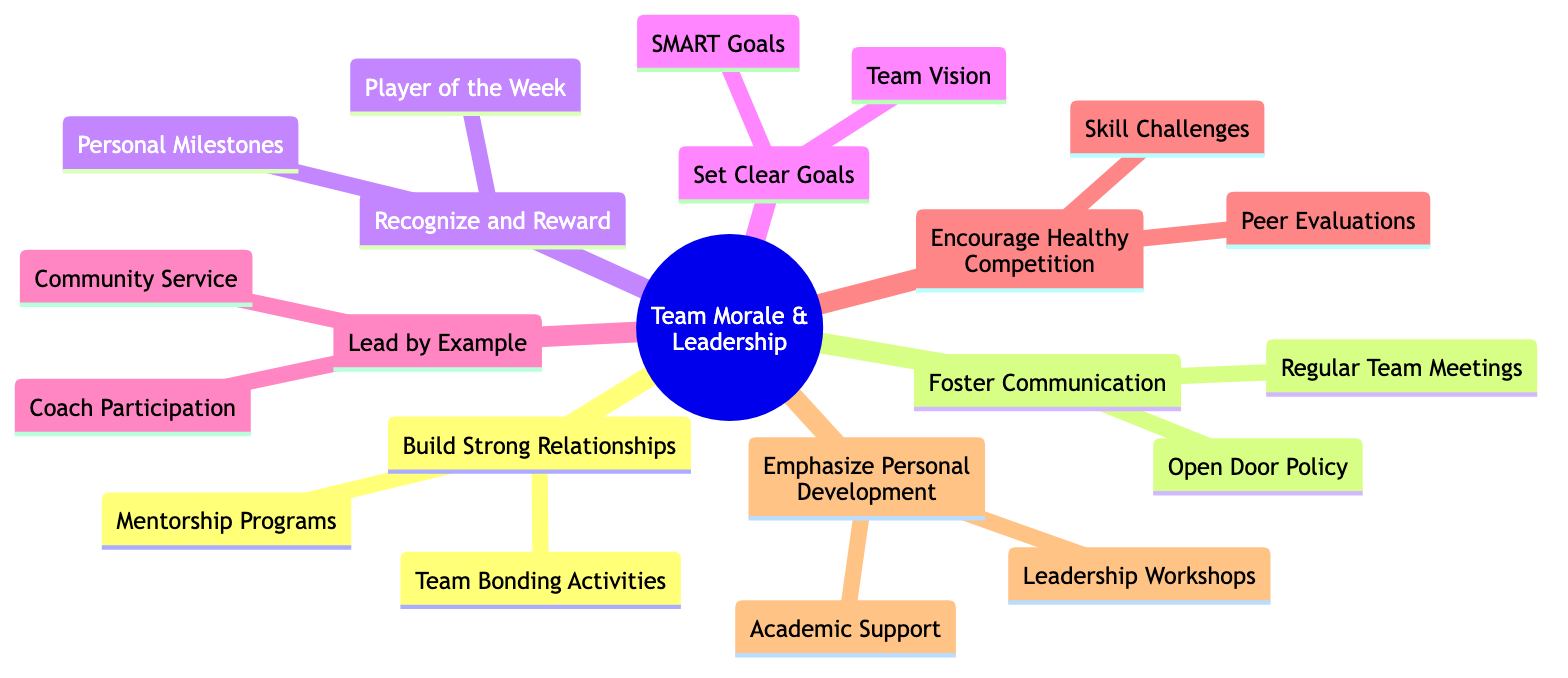What is one method for building strong relationships in the team? The diagram shows that one way to build strong relationships is through team bonding activities, which include organizing events like team dinners or movie nights.
Answer: Team Bonding Activities How many main strategies are outlined in the diagram? The diagram lists seven main strategies, each represented as a main branch extending from the central idea.
Answer: 7 What type of policy is encouraged to foster communication? The diagram indicates that an open door policy is suggested to encourage players to share their thoughts and concerns freely.
Answer: Open Door Policy What is the focus of the strategy 'Emphasize Personal Development'? The strategy emphasizes personal development through initiatives like leadership workshops and academic support for players.
Answer: Leadership Workshops How do 'Skill Challenges' contribute to team morale? Skill challenges are a method under the 'Encourage Healthy Competition' strategy, aiming to create friendly competition, which can boost team morale and motivation.
Answer: Skill Challenges What are the two specific activities listed under 'Recognize and Reward'? Under the 'Recognize and Reward' strategy, the activities highlighted are Player of the Week and Personal Milestones to appreciate players' achievements.
Answer: Player of the Week, Personal Milestones Which strategy involves crafting a collective vision statement? The strategy that involves crafting a collective vision statement with input from all players is 'Set Clear Goals.'
Answer: Set Clear Goals What is the relationship between 'Coach Participation' and 'Lead by Example'? 'Coach Participation' is a practice highlighted under the 'Lead by Example' strategy, indicating that coaches should actively demonstrate commitment through participation in drills.
Answer: Coach Participation Which strategy includes evaluating peer feedback? The diagram shows that evaluating peer feedback is part of the 'Encourage Healthy Competition' strategy, aimed at promoting constructive critiques among players.
Answer: Peer Evaluations 